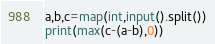<code> <loc_0><loc_0><loc_500><loc_500><_Python_>a,b,c=map(int,input().split())
print(max(c-(a-b),0))</code> 